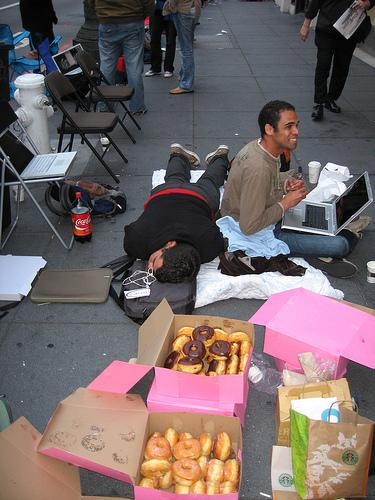Question: how many people are on the ground in the photo?
Choices:
A. Three.
B. Four.
C. Two.
D. Five.
Answer with the letter. Answer: C Question: what does the man in the tan shirt have in his lap?
Choices:
A. A box.
B. Laptop computer.
C. A plate of food.
D. A sandwich.
Answer with the letter. Answer: B Question: what color is the laptop?
Choices:
A. Green.
B. Red.
C. Black.
D. Silver.
Answer with the letter. Answer: D Question: what kind of frosting is on the donuts closest to the man in black's head?
Choices:
A. Vanilla.
B. Strawberry.
C. Blue with sprinkles.
D. Chocolate.
Answer with the letter. Answer: D Question: where is this scene taking place?
Choices:
A. At a wedding.
B. At a protest.
C. At a carnival.
D. At a street fair.
Answer with the letter. Answer: B 